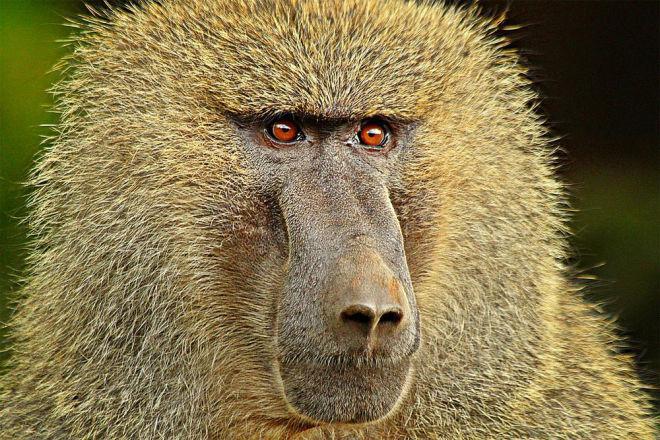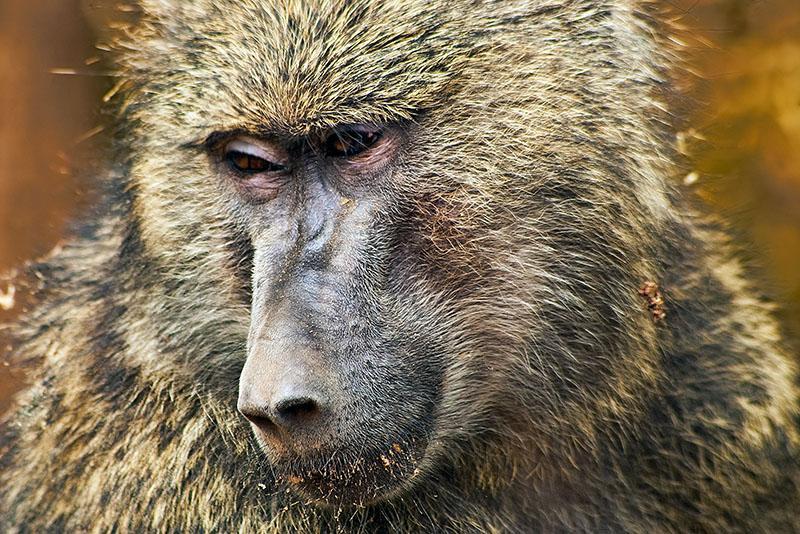The first image is the image on the left, the second image is the image on the right. Examine the images to the left and right. Is the description "The monkey in the left hand image has creepy red eyes." accurate? Answer yes or no. Yes. 